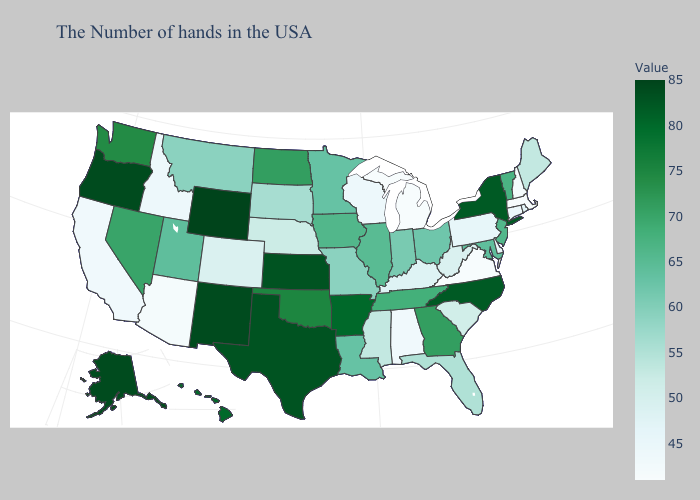Does Pennsylvania have a higher value than Kansas?
Answer briefly. No. Among the states that border North Carolina , which have the highest value?
Concise answer only. Georgia. Which states have the highest value in the USA?
Answer briefly. Wyoming. Which states have the lowest value in the USA?
Quick response, please. Massachusetts, Virginia, Michigan. Does Kansas have a lower value than Arizona?
Answer briefly. No. Which states have the lowest value in the South?
Be succinct. Virginia. Does Illinois have the lowest value in the MidWest?
Write a very short answer. No. Which states have the lowest value in the MidWest?
Short answer required. Michigan. Among the states that border North Carolina , which have the lowest value?
Quick response, please. Virginia. 